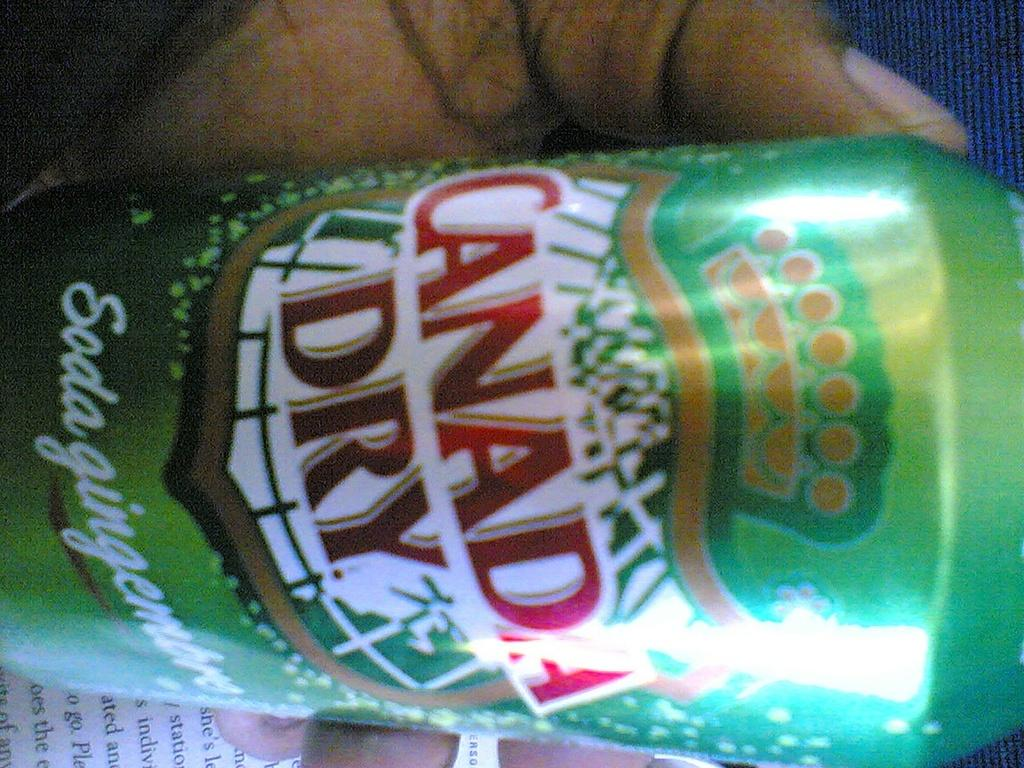<image>
Relay a brief, clear account of the picture shown. A side view of a Canada Dry can being held 